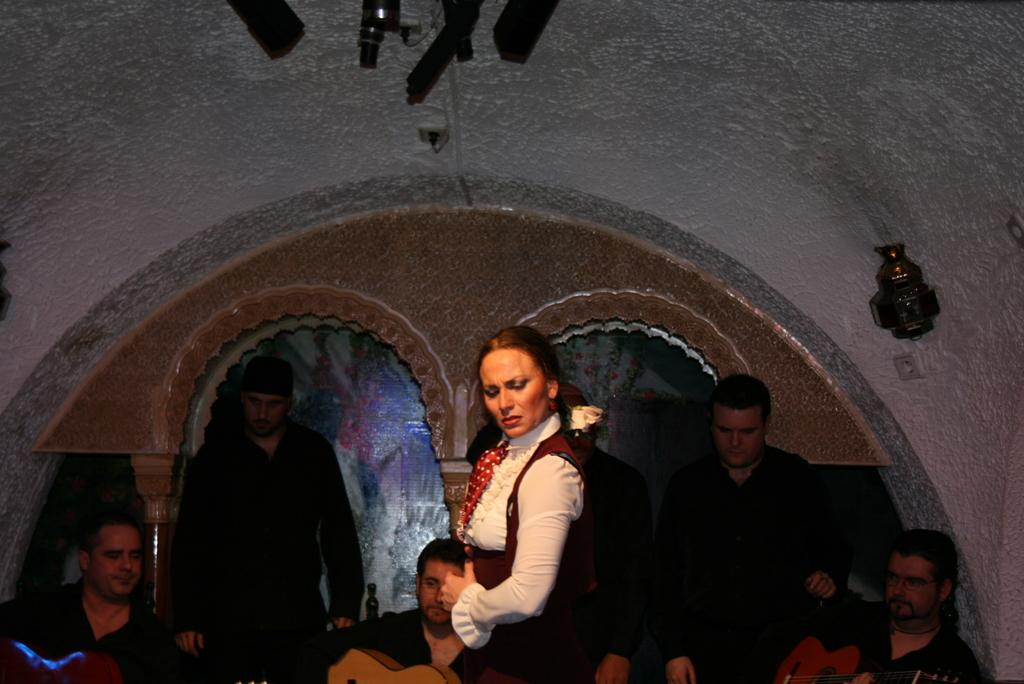What is the main subject of the image? The main subject of the image is a woman. What is the woman doing in the image? The woman is dancing in the image. Are there any other people in the image besides the woman? Yes, there are men in the image. What are the men doing in the image? The men are standing and playing guitar in the image. What type of lumber is the doctor using to treat the visitor in the image? There is no doctor, visitor, or lumber present in the image. 